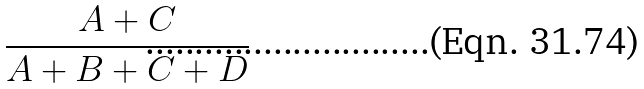<formula> <loc_0><loc_0><loc_500><loc_500>\frac { A + C } { A + B + C + D }</formula> 